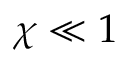<formula> <loc_0><loc_0><loc_500><loc_500>\chi \ll 1</formula> 